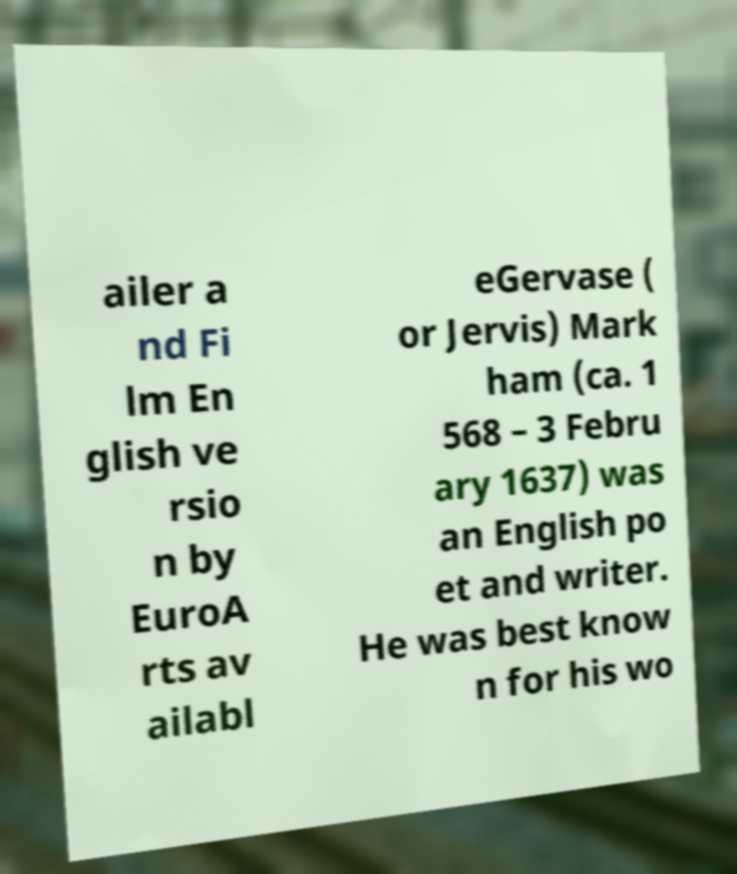Could you extract and type out the text from this image? ailer a nd Fi lm En glish ve rsio n by EuroA rts av ailabl eGervase ( or Jervis) Mark ham (ca. 1 568 – 3 Febru ary 1637) was an English po et and writer. He was best know n for his wo 